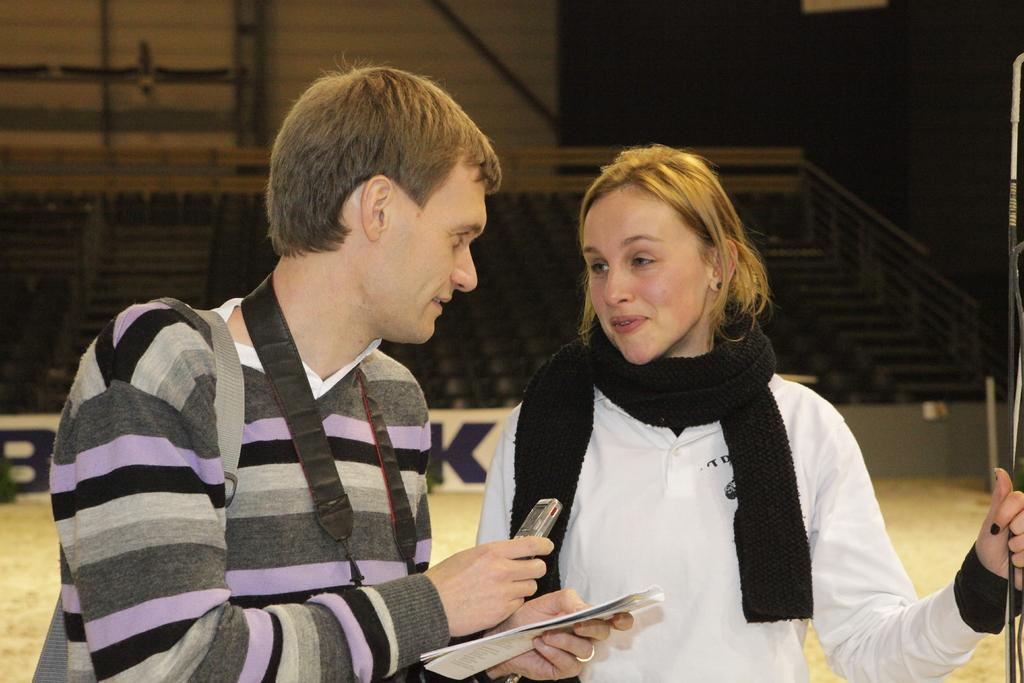Who can be seen in the foreground of the image? There is a man and a woman in the foreground of the image. What is the man holding in the image? The man is holding papers and a mobile phone. What architectural features can be seen in the background of the image? There are stairs, a railing, and a wall in the background of the image. What type of drum can be heard playing in the background of the image? There is no drum or sound present in the image; it is a still photograph. 